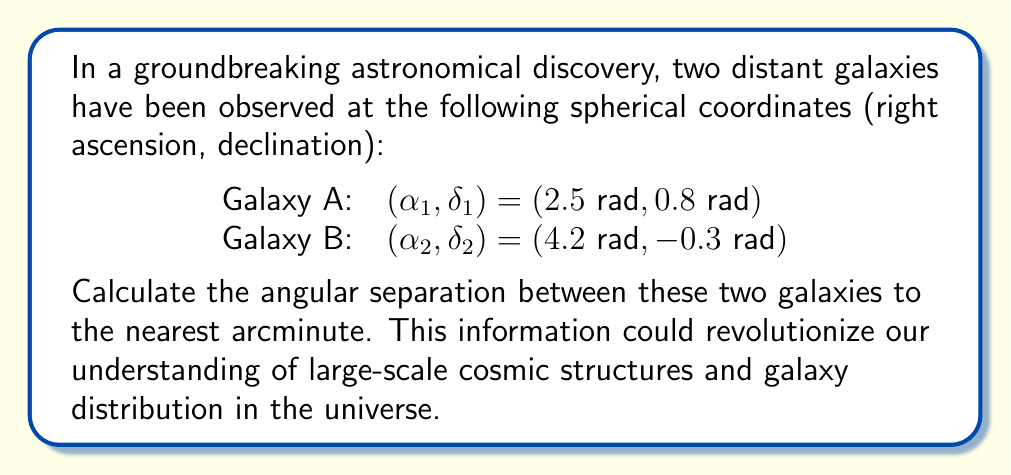Could you help me with this problem? To calculate the angular separation between two points on a celestial sphere, we use the great circle distance formula:

$$\cos(\theta) = \sin(\delta_1)\sin(\delta_2) + \cos(\delta_1)\cos(\delta_2)\cos(\alpha_2 - \alpha_1)$$

Where:
- $\theta$ is the angular separation
- $(\alpha_1, \delta_1)$ are the coordinates of Galaxy A
- $(\alpha_2, \delta_2)$ are the coordinates of Galaxy B

Let's solve this step-by-step:

1) First, let's calculate each term separately:

   $\sin(\delta_1) = \sin(0.8) \approx 0.7173$
   $\sin(\delta_2) = \sin(-0.3) \approx -0.2955$
   $\cos(\delta_1) = \cos(0.8) \approx 0.6967$
   $\cos(\delta_2) = \cos(-0.3) \approx 0.9553$
   $\cos(\alpha_2 - \alpha_1) = \cos(4.2 - 2.5) = \cos(1.7) \approx -0.1288$

2) Now, let's substitute these values into the formula:

   $\cos(\theta) = (0.7173 \times -0.2955) + (0.6967 \times 0.9553 \times -0.1288)$

3) Calculating:

   $\cos(\theta) = -0.2120 - 0.0857 = -0.2977$

4) To find $\theta$, we take the arccos of both sides:

   $\theta = \arccos(-0.2977) \approx 1.8657 \text{ radians}$

5) Convert radians to degrees:

   $\theta \approx 1.8657 \times \frac{180}{\pi} \approx 106.9°$

6) Convert the decimal part to arcminutes:

   $0.9° \times 60 = 54'$

Therefore, the angular separation is approximately 106° 54'.
Answer: 106° 54' 